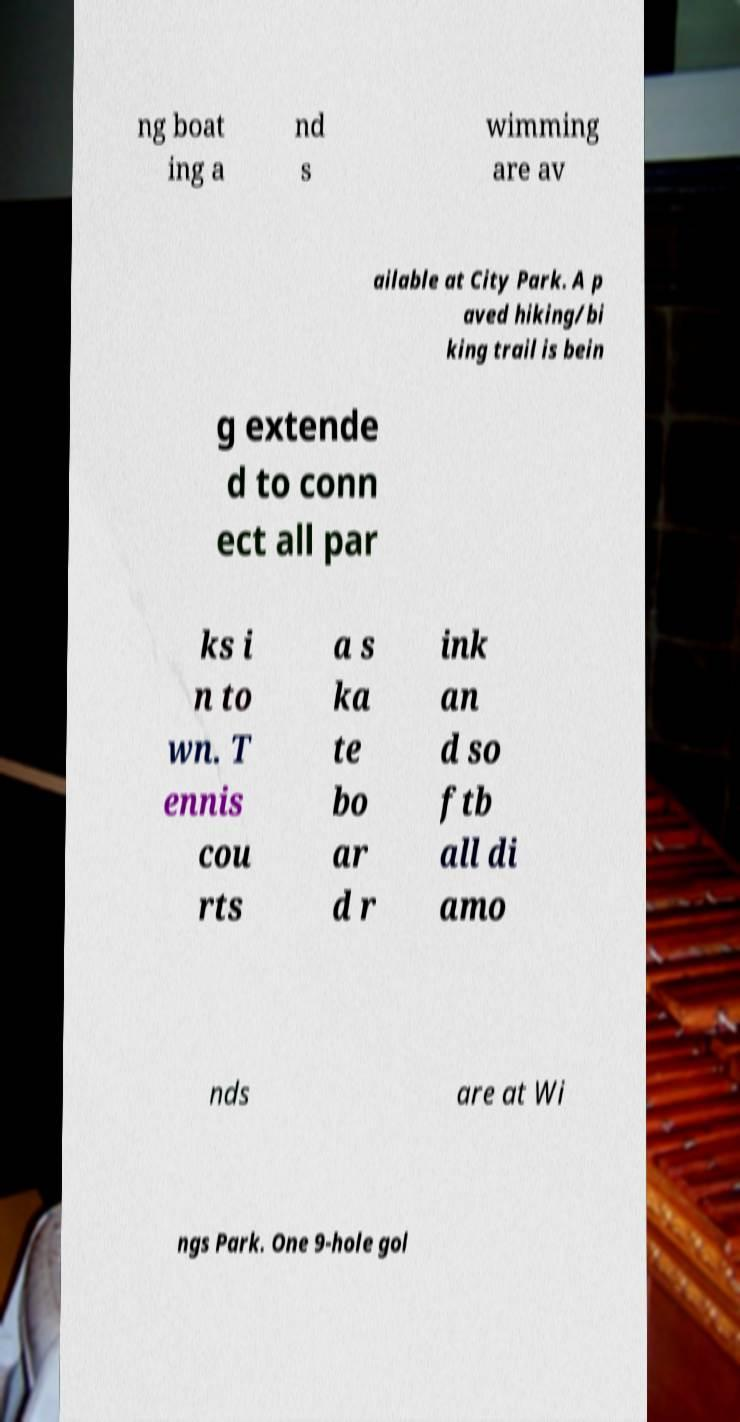Could you assist in decoding the text presented in this image and type it out clearly? ng boat ing a nd s wimming are av ailable at City Park. A p aved hiking/bi king trail is bein g extende d to conn ect all par ks i n to wn. T ennis cou rts a s ka te bo ar d r ink an d so ftb all di amo nds are at Wi ngs Park. One 9-hole gol 